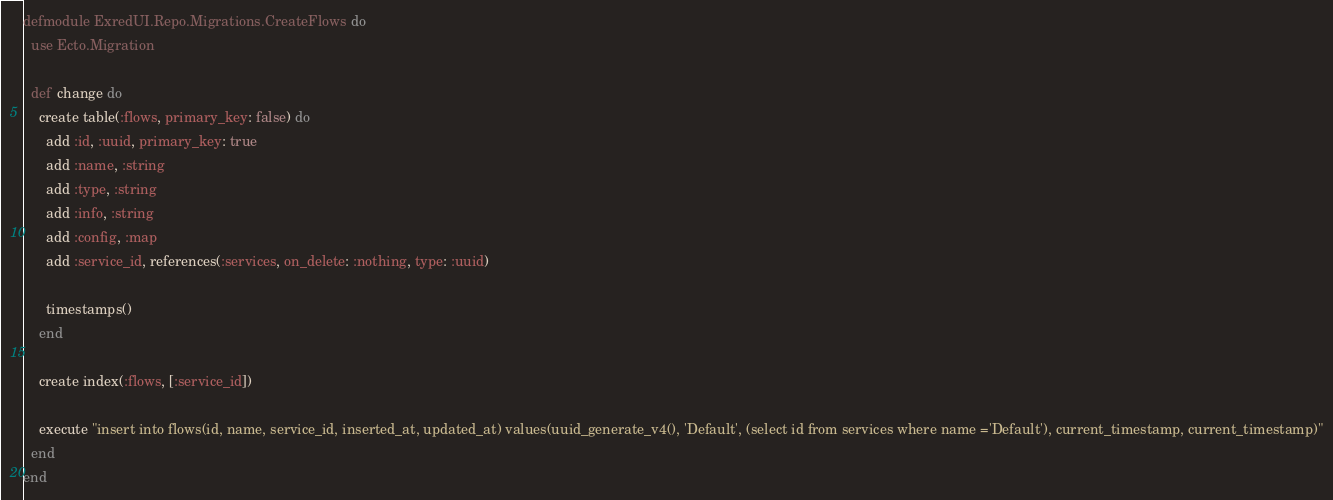Convert code to text. <code><loc_0><loc_0><loc_500><loc_500><_Elixir_>defmodule ExredUI.Repo.Migrations.CreateFlows do
  use Ecto.Migration

  def change do
    create table(:flows, primary_key: false) do
      add :id, :uuid, primary_key: true
      add :name, :string
      add :type, :string
      add :info, :string
      add :config, :map
      add :service_id, references(:services, on_delete: :nothing, type: :uuid)

      timestamps()
    end

    create index(:flows, [:service_id])

    execute "insert into flows(id, name, service_id, inserted_at, updated_at) values(uuid_generate_v4(), 'Default', (select id from services where name ='Default'), current_timestamp, current_timestamp)"
  end
end
</code> 